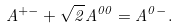Convert formula to latex. <formula><loc_0><loc_0><loc_500><loc_500>A ^ { + - } + \sqrt { 2 } A ^ { 0 0 } = A ^ { 0 - } .</formula> 